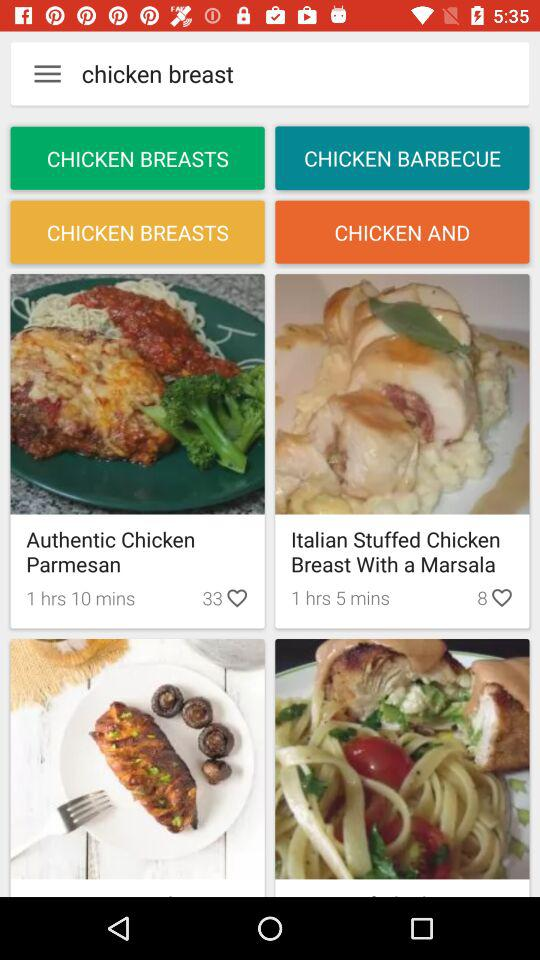What is the number of likes on "My moms chocolate cake"? The number of likes on "My moms chocolate cake" is 82. 